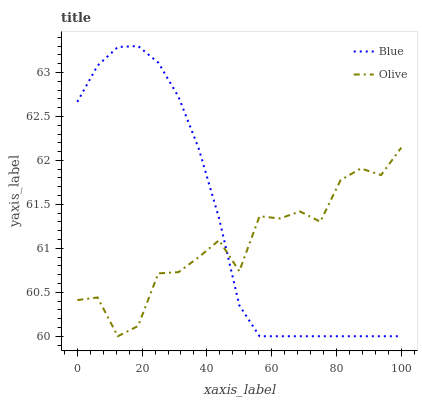Does Olive have the maximum area under the curve?
Answer yes or no. No. Is Olive the smoothest?
Answer yes or no. No. Does Olive have the highest value?
Answer yes or no. No. 